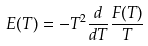Convert formula to latex. <formula><loc_0><loc_0><loc_500><loc_500>E ( T ) = - T ^ { 2 } \frac { d } { d T } \frac { F ( T ) } { T }</formula> 